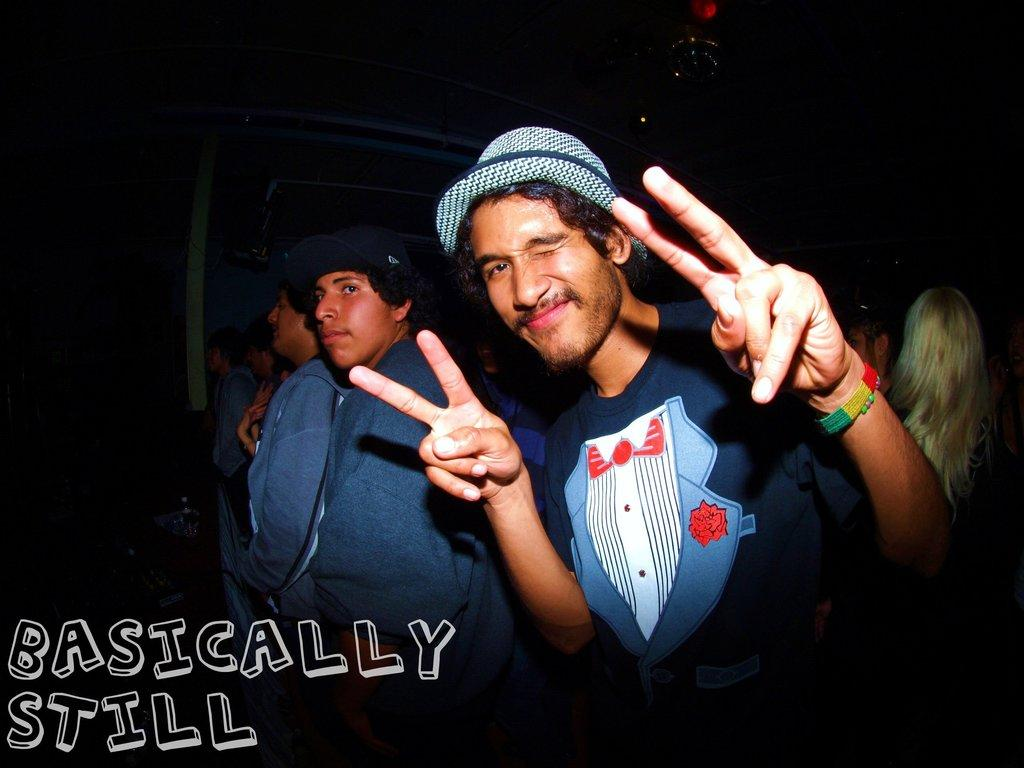How many people are in the image? There is a group of people in the image. Can you describe the clothing of one of the individuals? One person is wearing a dress and a hat. What is a notable characteristic of one of the women in the image? There is a woman with white hair in the image. What can be seen at the bottom of the image? There is text visible at the bottom of the image. What type of twig is being used as a prop in the image? There is: There is no twig present in the image. What flavor of butter is being served alongside the people in the image? There is no butter present in the image. 